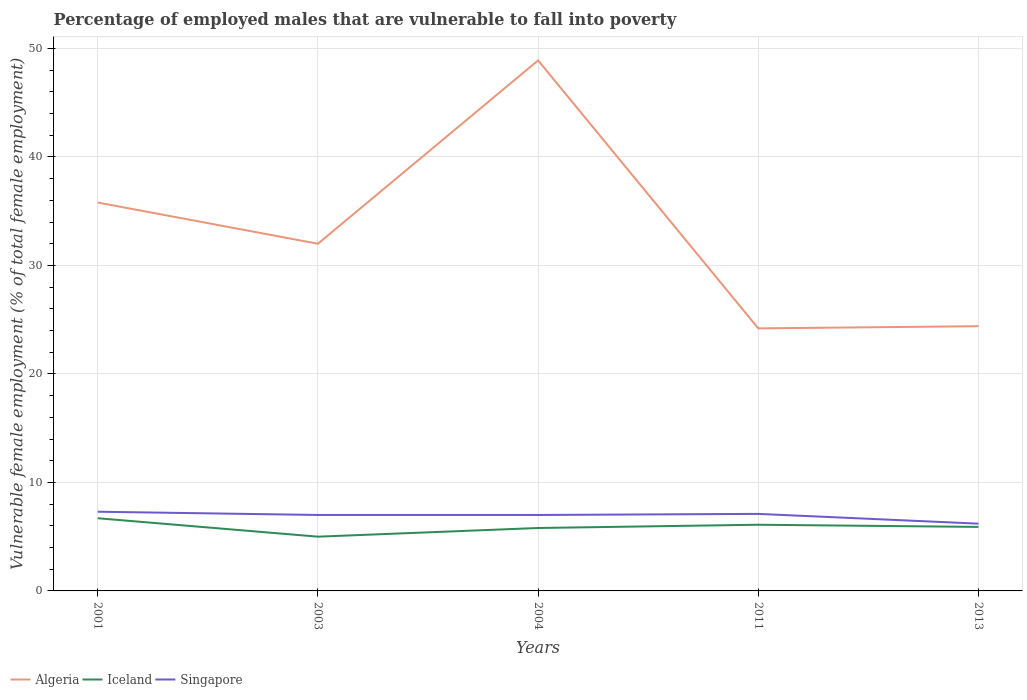How many different coloured lines are there?
Offer a very short reply. 3. Is the number of lines equal to the number of legend labels?
Your response must be concise. Yes. Across all years, what is the maximum percentage of employed males who are vulnerable to fall into poverty in Algeria?
Your answer should be compact. 24.2. In which year was the percentage of employed males who are vulnerable to fall into poverty in Iceland maximum?
Offer a very short reply. 2003. What is the total percentage of employed males who are vulnerable to fall into poverty in Iceland in the graph?
Your response must be concise. 0.8. What is the difference between the highest and the second highest percentage of employed males who are vulnerable to fall into poverty in Algeria?
Offer a terse response. 24.7. What is the difference between the highest and the lowest percentage of employed males who are vulnerable to fall into poverty in Singapore?
Your answer should be compact. 4. Is the percentage of employed males who are vulnerable to fall into poverty in Algeria strictly greater than the percentage of employed males who are vulnerable to fall into poverty in Singapore over the years?
Provide a succinct answer. No. How many lines are there?
Provide a succinct answer. 3. How many years are there in the graph?
Make the answer very short. 5. What is the difference between two consecutive major ticks on the Y-axis?
Your answer should be compact. 10. Are the values on the major ticks of Y-axis written in scientific E-notation?
Ensure brevity in your answer.  No. Does the graph contain any zero values?
Your answer should be very brief. No. Does the graph contain grids?
Provide a short and direct response. Yes. How are the legend labels stacked?
Provide a succinct answer. Horizontal. What is the title of the graph?
Offer a very short reply. Percentage of employed males that are vulnerable to fall into poverty. What is the label or title of the Y-axis?
Ensure brevity in your answer.  Vulnerable female employment (% of total female employment). What is the Vulnerable female employment (% of total female employment) of Algeria in 2001?
Keep it short and to the point. 35.8. What is the Vulnerable female employment (% of total female employment) in Iceland in 2001?
Offer a terse response. 6.7. What is the Vulnerable female employment (% of total female employment) of Singapore in 2001?
Offer a very short reply. 7.3. What is the Vulnerable female employment (% of total female employment) of Algeria in 2003?
Keep it short and to the point. 32. What is the Vulnerable female employment (% of total female employment) of Algeria in 2004?
Make the answer very short. 48.9. What is the Vulnerable female employment (% of total female employment) in Iceland in 2004?
Make the answer very short. 5.8. What is the Vulnerable female employment (% of total female employment) of Singapore in 2004?
Offer a very short reply. 7. What is the Vulnerable female employment (% of total female employment) in Algeria in 2011?
Make the answer very short. 24.2. What is the Vulnerable female employment (% of total female employment) of Iceland in 2011?
Provide a succinct answer. 6.1. What is the Vulnerable female employment (% of total female employment) in Singapore in 2011?
Provide a short and direct response. 7.1. What is the Vulnerable female employment (% of total female employment) of Algeria in 2013?
Make the answer very short. 24.4. What is the Vulnerable female employment (% of total female employment) in Iceland in 2013?
Offer a very short reply. 5.9. What is the Vulnerable female employment (% of total female employment) in Singapore in 2013?
Ensure brevity in your answer.  6.2. Across all years, what is the maximum Vulnerable female employment (% of total female employment) in Algeria?
Ensure brevity in your answer.  48.9. Across all years, what is the maximum Vulnerable female employment (% of total female employment) in Iceland?
Offer a very short reply. 6.7. Across all years, what is the maximum Vulnerable female employment (% of total female employment) of Singapore?
Offer a terse response. 7.3. Across all years, what is the minimum Vulnerable female employment (% of total female employment) of Algeria?
Make the answer very short. 24.2. Across all years, what is the minimum Vulnerable female employment (% of total female employment) of Iceland?
Provide a succinct answer. 5. Across all years, what is the minimum Vulnerable female employment (% of total female employment) in Singapore?
Keep it short and to the point. 6.2. What is the total Vulnerable female employment (% of total female employment) of Algeria in the graph?
Your answer should be very brief. 165.3. What is the total Vulnerable female employment (% of total female employment) of Iceland in the graph?
Provide a short and direct response. 29.5. What is the total Vulnerable female employment (% of total female employment) in Singapore in the graph?
Offer a very short reply. 34.6. What is the difference between the Vulnerable female employment (% of total female employment) of Algeria in 2001 and that in 2003?
Keep it short and to the point. 3.8. What is the difference between the Vulnerable female employment (% of total female employment) of Iceland in 2001 and that in 2003?
Keep it short and to the point. 1.7. What is the difference between the Vulnerable female employment (% of total female employment) in Singapore in 2001 and that in 2003?
Provide a short and direct response. 0.3. What is the difference between the Vulnerable female employment (% of total female employment) in Algeria in 2001 and that in 2011?
Your answer should be compact. 11.6. What is the difference between the Vulnerable female employment (% of total female employment) of Iceland in 2001 and that in 2011?
Your answer should be very brief. 0.6. What is the difference between the Vulnerable female employment (% of total female employment) of Singapore in 2001 and that in 2011?
Offer a very short reply. 0.2. What is the difference between the Vulnerable female employment (% of total female employment) of Iceland in 2001 and that in 2013?
Provide a succinct answer. 0.8. What is the difference between the Vulnerable female employment (% of total female employment) of Singapore in 2001 and that in 2013?
Ensure brevity in your answer.  1.1. What is the difference between the Vulnerable female employment (% of total female employment) in Algeria in 2003 and that in 2004?
Ensure brevity in your answer.  -16.9. What is the difference between the Vulnerable female employment (% of total female employment) in Algeria in 2003 and that in 2011?
Offer a terse response. 7.8. What is the difference between the Vulnerable female employment (% of total female employment) of Iceland in 2003 and that in 2011?
Provide a succinct answer. -1.1. What is the difference between the Vulnerable female employment (% of total female employment) in Singapore in 2003 and that in 2011?
Offer a very short reply. -0.1. What is the difference between the Vulnerable female employment (% of total female employment) in Algeria in 2003 and that in 2013?
Offer a very short reply. 7.6. What is the difference between the Vulnerable female employment (% of total female employment) of Algeria in 2004 and that in 2011?
Your answer should be compact. 24.7. What is the difference between the Vulnerable female employment (% of total female employment) in Singapore in 2004 and that in 2011?
Provide a short and direct response. -0.1. What is the difference between the Vulnerable female employment (% of total female employment) of Algeria in 2004 and that in 2013?
Ensure brevity in your answer.  24.5. What is the difference between the Vulnerable female employment (% of total female employment) of Iceland in 2004 and that in 2013?
Ensure brevity in your answer.  -0.1. What is the difference between the Vulnerable female employment (% of total female employment) of Algeria in 2011 and that in 2013?
Make the answer very short. -0.2. What is the difference between the Vulnerable female employment (% of total female employment) of Singapore in 2011 and that in 2013?
Your answer should be very brief. 0.9. What is the difference between the Vulnerable female employment (% of total female employment) of Algeria in 2001 and the Vulnerable female employment (% of total female employment) of Iceland in 2003?
Provide a short and direct response. 30.8. What is the difference between the Vulnerable female employment (% of total female employment) in Algeria in 2001 and the Vulnerable female employment (% of total female employment) in Singapore in 2003?
Make the answer very short. 28.8. What is the difference between the Vulnerable female employment (% of total female employment) of Iceland in 2001 and the Vulnerable female employment (% of total female employment) of Singapore in 2003?
Give a very brief answer. -0.3. What is the difference between the Vulnerable female employment (% of total female employment) of Algeria in 2001 and the Vulnerable female employment (% of total female employment) of Iceland in 2004?
Keep it short and to the point. 30. What is the difference between the Vulnerable female employment (% of total female employment) in Algeria in 2001 and the Vulnerable female employment (% of total female employment) in Singapore in 2004?
Your answer should be very brief. 28.8. What is the difference between the Vulnerable female employment (% of total female employment) in Iceland in 2001 and the Vulnerable female employment (% of total female employment) in Singapore in 2004?
Offer a terse response. -0.3. What is the difference between the Vulnerable female employment (% of total female employment) of Algeria in 2001 and the Vulnerable female employment (% of total female employment) of Iceland in 2011?
Ensure brevity in your answer.  29.7. What is the difference between the Vulnerable female employment (% of total female employment) in Algeria in 2001 and the Vulnerable female employment (% of total female employment) in Singapore in 2011?
Your response must be concise. 28.7. What is the difference between the Vulnerable female employment (% of total female employment) of Iceland in 2001 and the Vulnerable female employment (% of total female employment) of Singapore in 2011?
Offer a terse response. -0.4. What is the difference between the Vulnerable female employment (% of total female employment) in Algeria in 2001 and the Vulnerable female employment (% of total female employment) in Iceland in 2013?
Your answer should be very brief. 29.9. What is the difference between the Vulnerable female employment (% of total female employment) in Algeria in 2001 and the Vulnerable female employment (% of total female employment) in Singapore in 2013?
Make the answer very short. 29.6. What is the difference between the Vulnerable female employment (% of total female employment) in Iceland in 2001 and the Vulnerable female employment (% of total female employment) in Singapore in 2013?
Offer a terse response. 0.5. What is the difference between the Vulnerable female employment (% of total female employment) of Algeria in 2003 and the Vulnerable female employment (% of total female employment) of Iceland in 2004?
Ensure brevity in your answer.  26.2. What is the difference between the Vulnerable female employment (% of total female employment) in Algeria in 2003 and the Vulnerable female employment (% of total female employment) in Singapore in 2004?
Your response must be concise. 25. What is the difference between the Vulnerable female employment (% of total female employment) in Algeria in 2003 and the Vulnerable female employment (% of total female employment) in Iceland in 2011?
Ensure brevity in your answer.  25.9. What is the difference between the Vulnerable female employment (% of total female employment) in Algeria in 2003 and the Vulnerable female employment (% of total female employment) in Singapore in 2011?
Ensure brevity in your answer.  24.9. What is the difference between the Vulnerable female employment (% of total female employment) in Algeria in 2003 and the Vulnerable female employment (% of total female employment) in Iceland in 2013?
Offer a very short reply. 26.1. What is the difference between the Vulnerable female employment (% of total female employment) of Algeria in 2003 and the Vulnerable female employment (% of total female employment) of Singapore in 2013?
Your answer should be very brief. 25.8. What is the difference between the Vulnerable female employment (% of total female employment) of Iceland in 2003 and the Vulnerable female employment (% of total female employment) of Singapore in 2013?
Keep it short and to the point. -1.2. What is the difference between the Vulnerable female employment (% of total female employment) of Algeria in 2004 and the Vulnerable female employment (% of total female employment) of Iceland in 2011?
Your answer should be very brief. 42.8. What is the difference between the Vulnerable female employment (% of total female employment) in Algeria in 2004 and the Vulnerable female employment (% of total female employment) in Singapore in 2011?
Make the answer very short. 41.8. What is the difference between the Vulnerable female employment (% of total female employment) in Iceland in 2004 and the Vulnerable female employment (% of total female employment) in Singapore in 2011?
Offer a very short reply. -1.3. What is the difference between the Vulnerable female employment (% of total female employment) of Algeria in 2004 and the Vulnerable female employment (% of total female employment) of Singapore in 2013?
Provide a succinct answer. 42.7. What is the difference between the Vulnerable female employment (% of total female employment) in Algeria in 2011 and the Vulnerable female employment (% of total female employment) in Iceland in 2013?
Your answer should be compact. 18.3. What is the average Vulnerable female employment (% of total female employment) of Algeria per year?
Keep it short and to the point. 33.06. What is the average Vulnerable female employment (% of total female employment) in Singapore per year?
Your answer should be compact. 6.92. In the year 2001, what is the difference between the Vulnerable female employment (% of total female employment) of Algeria and Vulnerable female employment (% of total female employment) of Iceland?
Make the answer very short. 29.1. In the year 2001, what is the difference between the Vulnerable female employment (% of total female employment) in Iceland and Vulnerable female employment (% of total female employment) in Singapore?
Keep it short and to the point. -0.6. In the year 2003, what is the difference between the Vulnerable female employment (% of total female employment) of Algeria and Vulnerable female employment (% of total female employment) of Iceland?
Keep it short and to the point. 27. In the year 2003, what is the difference between the Vulnerable female employment (% of total female employment) in Algeria and Vulnerable female employment (% of total female employment) in Singapore?
Make the answer very short. 25. In the year 2004, what is the difference between the Vulnerable female employment (% of total female employment) of Algeria and Vulnerable female employment (% of total female employment) of Iceland?
Ensure brevity in your answer.  43.1. In the year 2004, what is the difference between the Vulnerable female employment (% of total female employment) in Algeria and Vulnerable female employment (% of total female employment) in Singapore?
Keep it short and to the point. 41.9. In the year 2011, what is the difference between the Vulnerable female employment (% of total female employment) of Algeria and Vulnerable female employment (% of total female employment) of Iceland?
Your response must be concise. 18.1. In the year 2011, what is the difference between the Vulnerable female employment (% of total female employment) of Iceland and Vulnerable female employment (% of total female employment) of Singapore?
Give a very brief answer. -1. In the year 2013, what is the difference between the Vulnerable female employment (% of total female employment) of Algeria and Vulnerable female employment (% of total female employment) of Iceland?
Keep it short and to the point. 18.5. In the year 2013, what is the difference between the Vulnerable female employment (% of total female employment) of Algeria and Vulnerable female employment (% of total female employment) of Singapore?
Ensure brevity in your answer.  18.2. What is the ratio of the Vulnerable female employment (% of total female employment) of Algeria in 2001 to that in 2003?
Provide a short and direct response. 1.12. What is the ratio of the Vulnerable female employment (% of total female employment) in Iceland in 2001 to that in 2003?
Offer a very short reply. 1.34. What is the ratio of the Vulnerable female employment (% of total female employment) of Singapore in 2001 to that in 2003?
Your response must be concise. 1.04. What is the ratio of the Vulnerable female employment (% of total female employment) of Algeria in 2001 to that in 2004?
Give a very brief answer. 0.73. What is the ratio of the Vulnerable female employment (% of total female employment) in Iceland in 2001 to that in 2004?
Offer a terse response. 1.16. What is the ratio of the Vulnerable female employment (% of total female employment) in Singapore in 2001 to that in 2004?
Give a very brief answer. 1.04. What is the ratio of the Vulnerable female employment (% of total female employment) of Algeria in 2001 to that in 2011?
Your response must be concise. 1.48. What is the ratio of the Vulnerable female employment (% of total female employment) of Iceland in 2001 to that in 2011?
Offer a very short reply. 1.1. What is the ratio of the Vulnerable female employment (% of total female employment) of Singapore in 2001 to that in 2011?
Provide a succinct answer. 1.03. What is the ratio of the Vulnerable female employment (% of total female employment) of Algeria in 2001 to that in 2013?
Ensure brevity in your answer.  1.47. What is the ratio of the Vulnerable female employment (% of total female employment) of Iceland in 2001 to that in 2013?
Make the answer very short. 1.14. What is the ratio of the Vulnerable female employment (% of total female employment) in Singapore in 2001 to that in 2013?
Ensure brevity in your answer.  1.18. What is the ratio of the Vulnerable female employment (% of total female employment) of Algeria in 2003 to that in 2004?
Offer a terse response. 0.65. What is the ratio of the Vulnerable female employment (% of total female employment) in Iceland in 2003 to that in 2004?
Make the answer very short. 0.86. What is the ratio of the Vulnerable female employment (% of total female employment) of Singapore in 2003 to that in 2004?
Give a very brief answer. 1. What is the ratio of the Vulnerable female employment (% of total female employment) in Algeria in 2003 to that in 2011?
Make the answer very short. 1.32. What is the ratio of the Vulnerable female employment (% of total female employment) in Iceland in 2003 to that in 2011?
Offer a terse response. 0.82. What is the ratio of the Vulnerable female employment (% of total female employment) in Singapore in 2003 to that in 2011?
Offer a very short reply. 0.99. What is the ratio of the Vulnerable female employment (% of total female employment) of Algeria in 2003 to that in 2013?
Your answer should be very brief. 1.31. What is the ratio of the Vulnerable female employment (% of total female employment) of Iceland in 2003 to that in 2013?
Make the answer very short. 0.85. What is the ratio of the Vulnerable female employment (% of total female employment) of Singapore in 2003 to that in 2013?
Your answer should be compact. 1.13. What is the ratio of the Vulnerable female employment (% of total female employment) of Algeria in 2004 to that in 2011?
Keep it short and to the point. 2.02. What is the ratio of the Vulnerable female employment (% of total female employment) of Iceland in 2004 to that in 2011?
Ensure brevity in your answer.  0.95. What is the ratio of the Vulnerable female employment (% of total female employment) of Singapore in 2004 to that in 2011?
Offer a terse response. 0.99. What is the ratio of the Vulnerable female employment (% of total female employment) in Algeria in 2004 to that in 2013?
Your response must be concise. 2. What is the ratio of the Vulnerable female employment (% of total female employment) of Iceland in 2004 to that in 2013?
Offer a terse response. 0.98. What is the ratio of the Vulnerable female employment (% of total female employment) of Singapore in 2004 to that in 2013?
Ensure brevity in your answer.  1.13. What is the ratio of the Vulnerable female employment (% of total female employment) in Iceland in 2011 to that in 2013?
Make the answer very short. 1.03. What is the ratio of the Vulnerable female employment (% of total female employment) of Singapore in 2011 to that in 2013?
Your answer should be compact. 1.15. What is the difference between the highest and the second highest Vulnerable female employment (% of total female employment) of Algeria?
Provide a short and direct response. 13.1. What is the difference between the highest and the second highest Vulnerable female employment (% of total female employment) in Iceland?
Your answer should be compact. 0.6. What is the difference between the highest and the second highest Vulnerable female employment (% of total female employment) in Singapore?
Make the answer very short. 0.2. What is the difference between the highest and the lowest Vulnerable female employment (% of total female employment) of Algeria?
Offer a terse response. 24.7. What is the difference between the highest and the lowest Vulnerable female employment (% of total female employment) of Iceland?
Provide a succinct answer. 1.7. 